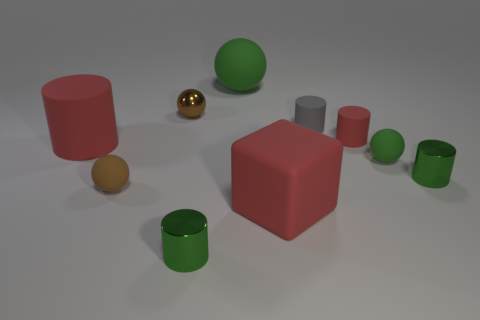There is a red thing that is behind the red rubber block and on the right side of the big sphere; what is its size?
Your response must be concise. Small. The gray rubber object is what shape?
Offer a very short reply. Cylinder. There is a small shiny cylinder on the right side of the gray matte cylinder; are there any tiny balls that are in front of it?
Offer a terse response. Yes. There is a green shiny cylinder that is to the left of the gray rubber cylinder; what number of green metal objects are right of it?
Keep it short and to the point. 1. What material is the brown ball that is the same size as the brown matte thing?
Keep it short and to the point. Metal. There is a green metal thing that is right of the tiny red cylinder; is it the same shape as the small brown metal object?
Your response must be concise. No. Are there more small cylinders that are on the right side of the small gray rubber thing than large rubber objects that are behind the large red block?
Provide a short and direct response. No. What number of cylinders are made of the same material as the tiny gray object?
Keep it short and to the point. 2. Does the metallic ball have the same size as the gray thing?
Keep it short and to the point. Yes. The matte block is what color?
Provide a succinct answer. Red. 